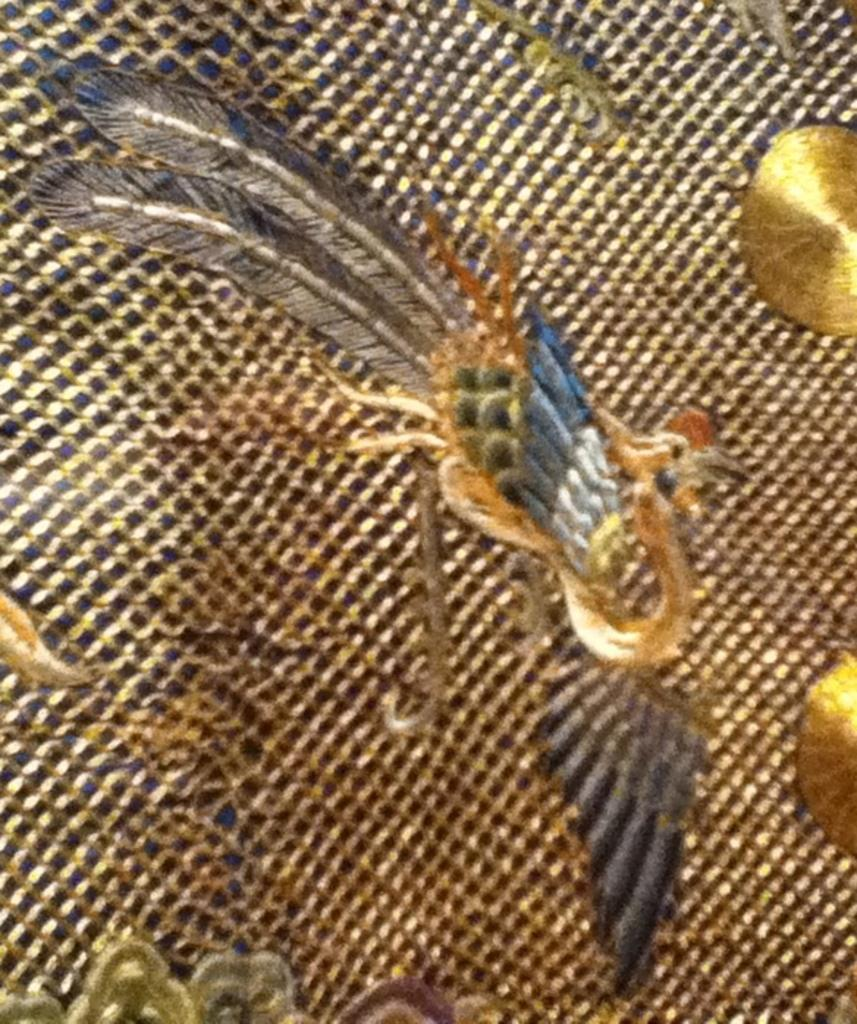What is the main subject of the image? The main subject of the image is art on a metal body. Can you describe the art in the image? Unfortunately, the description of the art is not provided in the facts. What material is the body of the subject made of? The body of the subject is made of metal. How many roses are depicted in the art on the metal body? There is no information about roses or any specific details of the art in the image, so we cannot answer this question. 